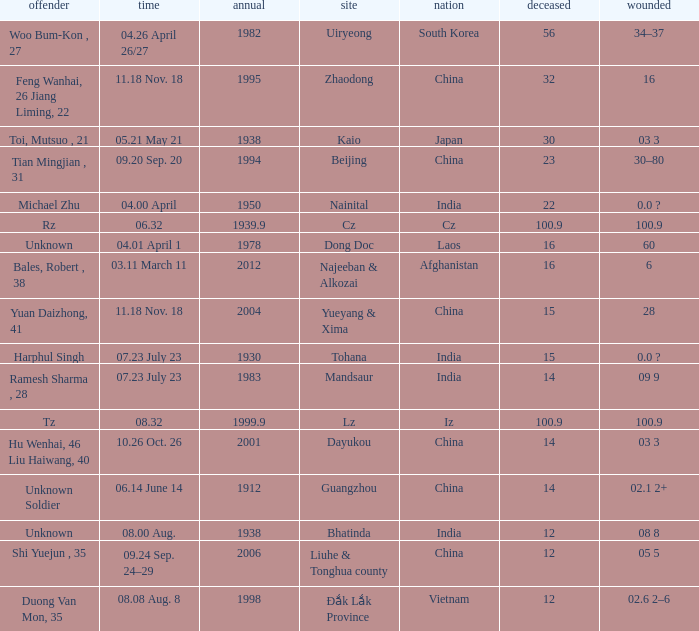What is Date, when Country is "China", and when Perpetrator is "Shi Yuejun , 35"? 09.24 Sep. 24–29. 